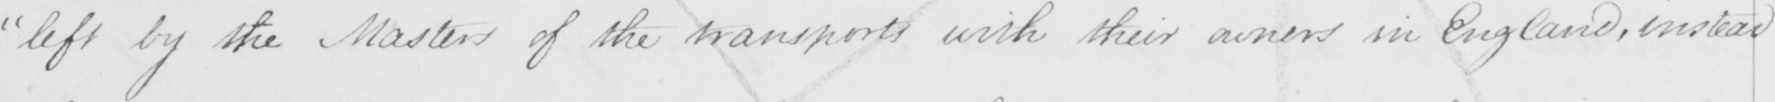Please transcribe the handwritten text in this image. " left by the Masters of the transports with their owners in England , instead 